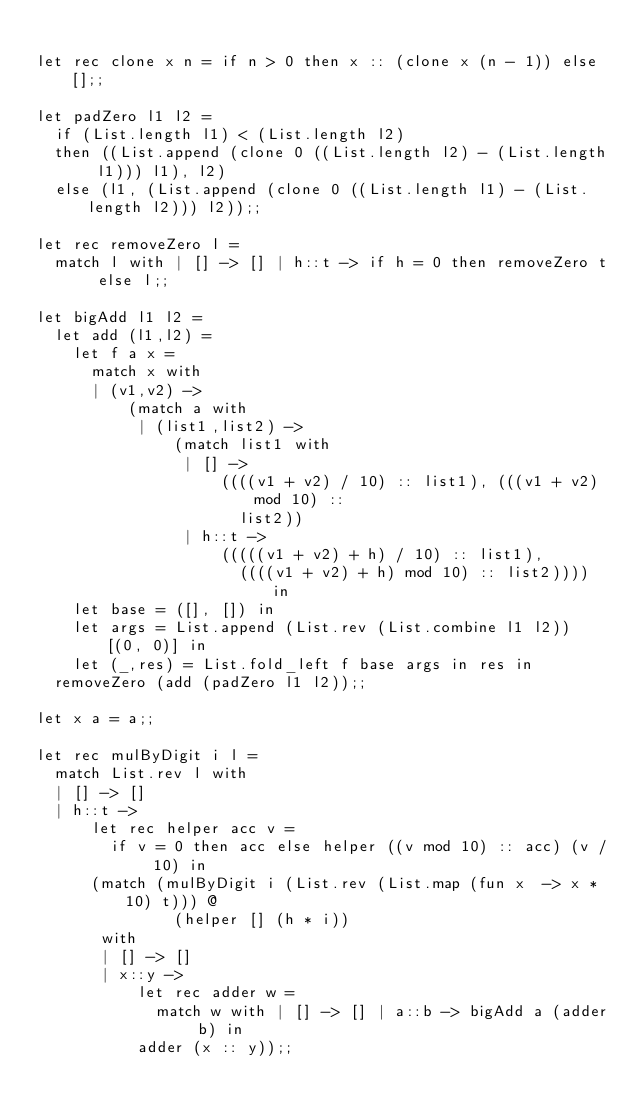<code> <loc_0><loc_0><loc_500><loc_500><_OCaml_>
let rec clone x n = if n > 0 then x :: (clone x (n - 1)) else [];;

let padZero l1 l2 =
  if (List.length l1) < (List.length l2)
  then ((List.append (clone 0 ((List.length l2) - (List.length l1))) l1), l2)
  else (l1, (List.append (clone 0 ((List.length l1) - (List.length l2))) l2));;

let rec removeZero l =
  match l with | [] -> [] | h::t -> if h = 0 then removeZero t else l;;

let bigAdd l1 l2 =
  let add (l1,l2) =
    let f a x =
      match x with
      | (v1,v2) ->
          (match a with
           | (list1,list2) ->
               (match list1 with
                | [] ->
                    ((((v1 + v2) / 10) :: list1), (((v1 + v2) mod 10) ::
                      list2))
                | h::t ->
                    (((((v1 + v2) + h) / 10) :: list1),
                      ((((v1 + v2) + h) mod 10) :: list2)))) in
    let base = ([], []) in
    let args = List.append (List.rev (List.combine l1 l2)) [(0, 0)] in
    let (_,res) = List.fold_left f base args in res in
  removeZero (add (padZero l1 l2));;

let x a = a;;

let rec mulByDigit i l =
  match List.rev l with
  | [] -> []
  | h::t ->
      let rec helper acc v =
        if v = 0 then acc else helper ((v mod 10) :: acc) (v / 10) in
      (match (mulByDigit i (List.rev (List.map (fun x  -> x * 10) t))) @
               (helper [] (h * i))
       with
       | [] -> []
       | x::y ->
           let rec adder w =
             match w with | [] -> [] | a::b -> bigAdd a (adder b) in
           adder (x :: y));;
</code> 